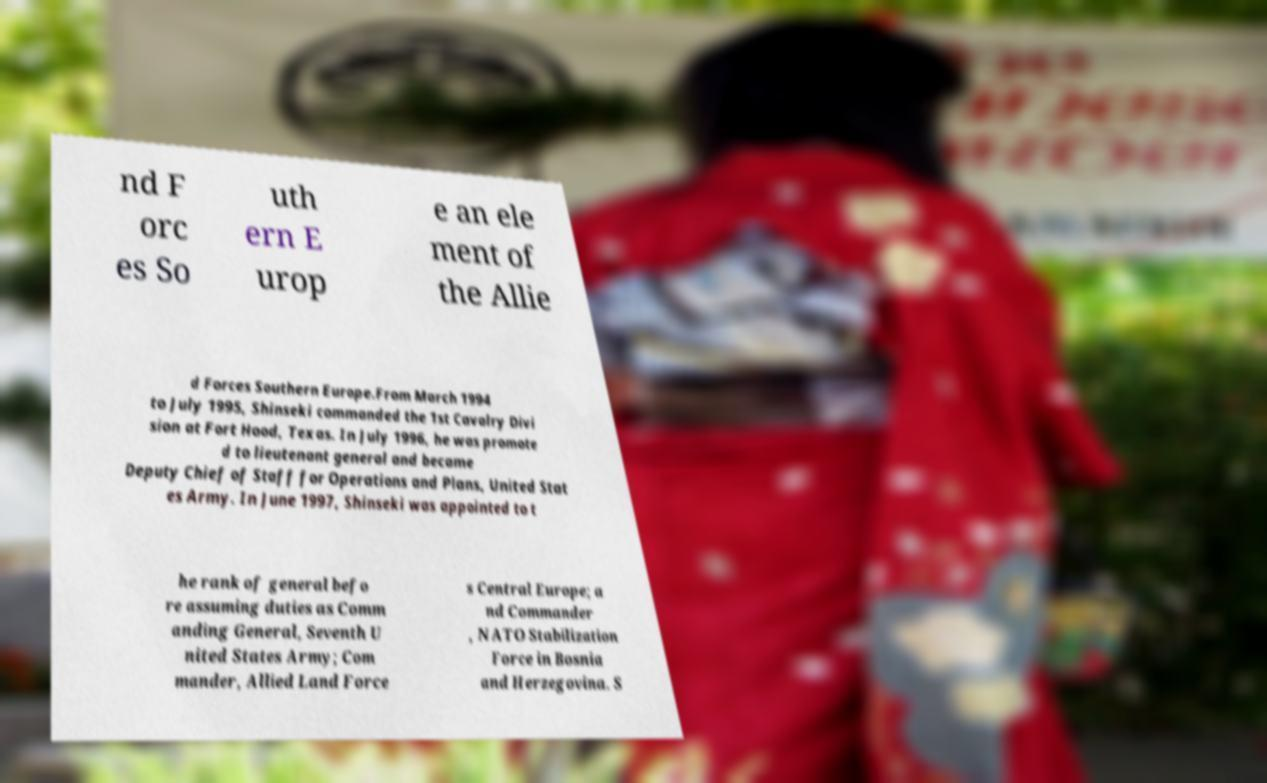Can you accurately transcribe the text from the provided image for me? nd F orc es So uth ern E urop e an ele ment of the Allie d Forces Southern Europe.From March 1994 to July 1995, Shinseki commanded the 1st Cavalry Divi sion at Fort Hood, Texas. In July 1996, he was promote d to lieutenant general and became Deputy Chief of Staff for Operations and Plans, United Stat es Army. In June 1997, Shinseki was appointed to t he rank of general befo re assuming duties as Comm anding General, Seventh U nited States Army; Com mander, Allied Land Force s Central Europe; a nd Commander , NATO Stabilization Force in Bosnia and Herzegovina. S 